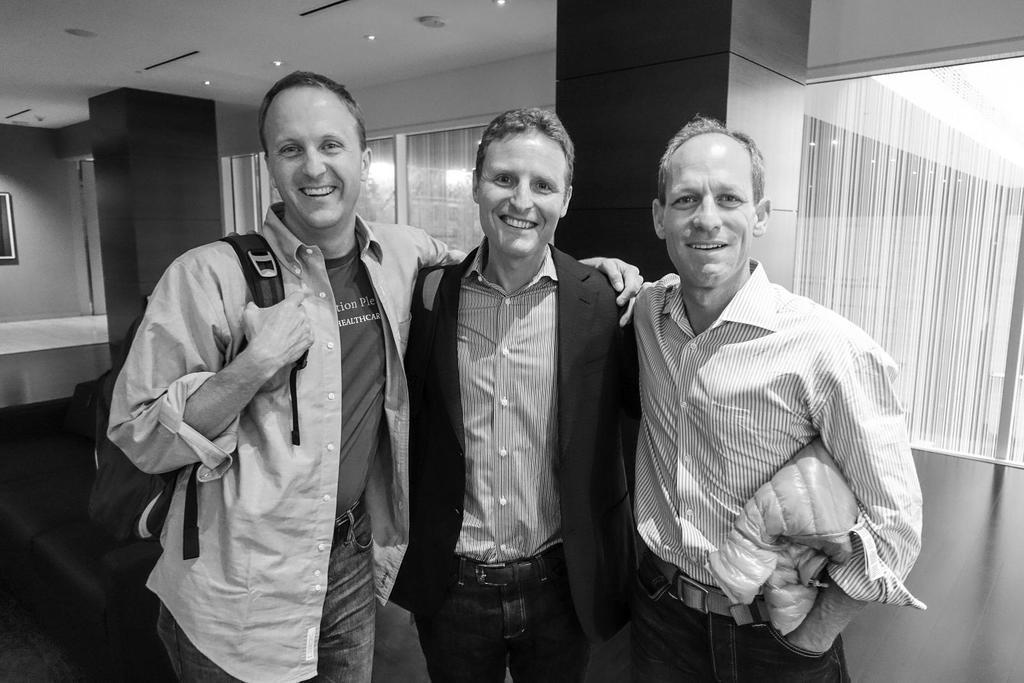Can you describe this image briefly? In this image we can see three people standing and smiling. In the background there are windows and we can see blinds. At the top there are lights and there is a sofa. 